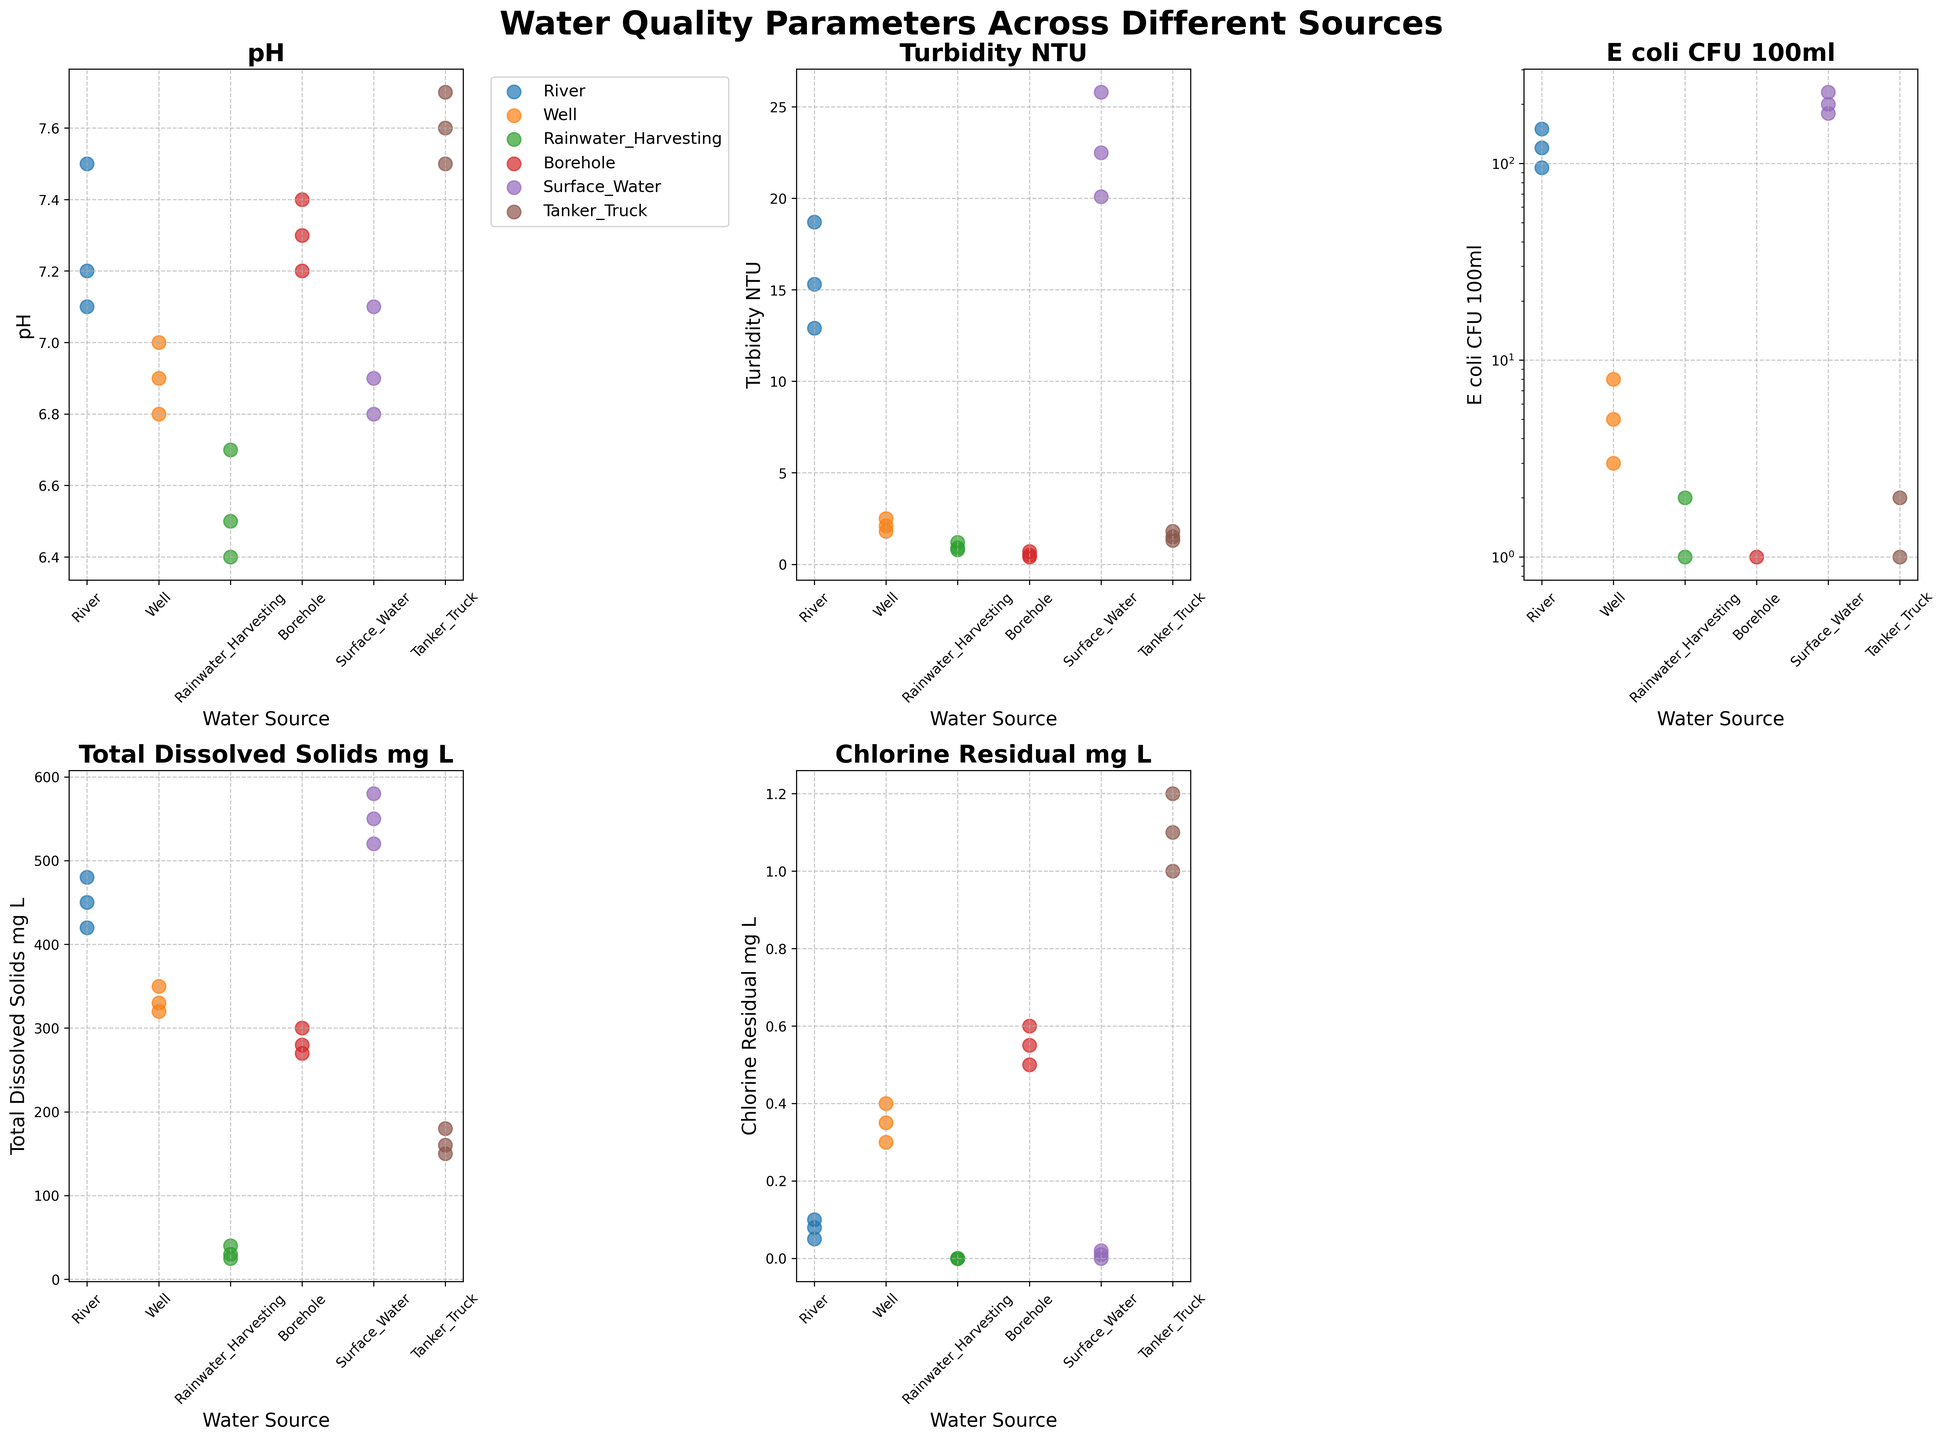Which water source has the highest pH? By visually inspecting the 'pH' subplot, identify the water source with the highest pH value. The highest pH value can be observed for the Tanker Truck water source.
Answer: Tanker Truck Which water source has the lowest turbidity? By visually inspecting the 'Turbidity_NTU' subplot, identify the water source with the lowest turbidity value. The lowest turbidity value can be observed for the Borehole water source.
Answer: Borehole How does the E. coli count in river water compare to well water? In the 'E_coli_CFU_100ml' subplot, compare the E. coli counts of water sources from River and Well. River water has a significantly higher E. coli count compared to Well water.
Answer: River has higher E. coli count Which water source has the highest total dissolved solids? By visually inspecting the 'Total_Dissolved_Solids_mg_L' subplot, identify the water source with the highest total dissolved solids value. The highest TDS value can be observed for the Surface Water source.
Answer: Surface Water Which water source has the highest chlorine residual? By visually inspecting the 'Chlorine_Residual_mg_L' subplot, identify the water source with the highest chlorine residual value. The highest chlorine residual value can be observed for the Tanker Truck water source.
Answer: Tanker Truck What is the average pH of water from boreholes? By observing the 'pH' subplot, sum up the pH values for Borehole water (7.3, 7.4, 7.2) and divide by the number of measurements, which is 3. The average pH value is (7.3+7.4+7.2)/3 = 7.30.
Answer: 7.30 Compare the turbidity levels between surface water and rainwater harvesting. Which has higher turbidity on average? In the 'Turbidity_NTU' subplot, identify the turbidity values for Surface Water (22.5, 25.8, 20.1) and Rainwater Harvesting (0.8, 1.2, 0.9). Calculate the average turbidity for each. Surface Water: (22.5+25.8+20.1)/3 = 22.80, Rainwater Harvesting: (0.8+1.2+0.9)/3 = 0.97. Surface Water has higher turbidity on average.
Answer: Surface Water Which water source(s) have zero chlorine residual? By visually inspecting the 'Chlorine_Residual_mg_L' subplot, identify water sources with zero chlorine residual values. Rainwater Harvesting and Surface Water have zero chlorine residual values.
Answer: Rainwater Harvesting, Surface Water By how much does the total dissolved solids in tanker truck water differ from river water on average? Identify the TDS values for Tanker Truck (150, 180, 160) and River (450, 480, 420) from the 'Total_Dissolved_Solids_mg_L' subplot. Calculate the average TDS for both: Tanker Truck: (150+180+160)/3 = 163.33, River: (450+480+420)/3 = 450. Difference: 450 - 163.33 = 286.67. The average difference in TDS is approximately 287 mg/L.
Answer: 287 mg/L 